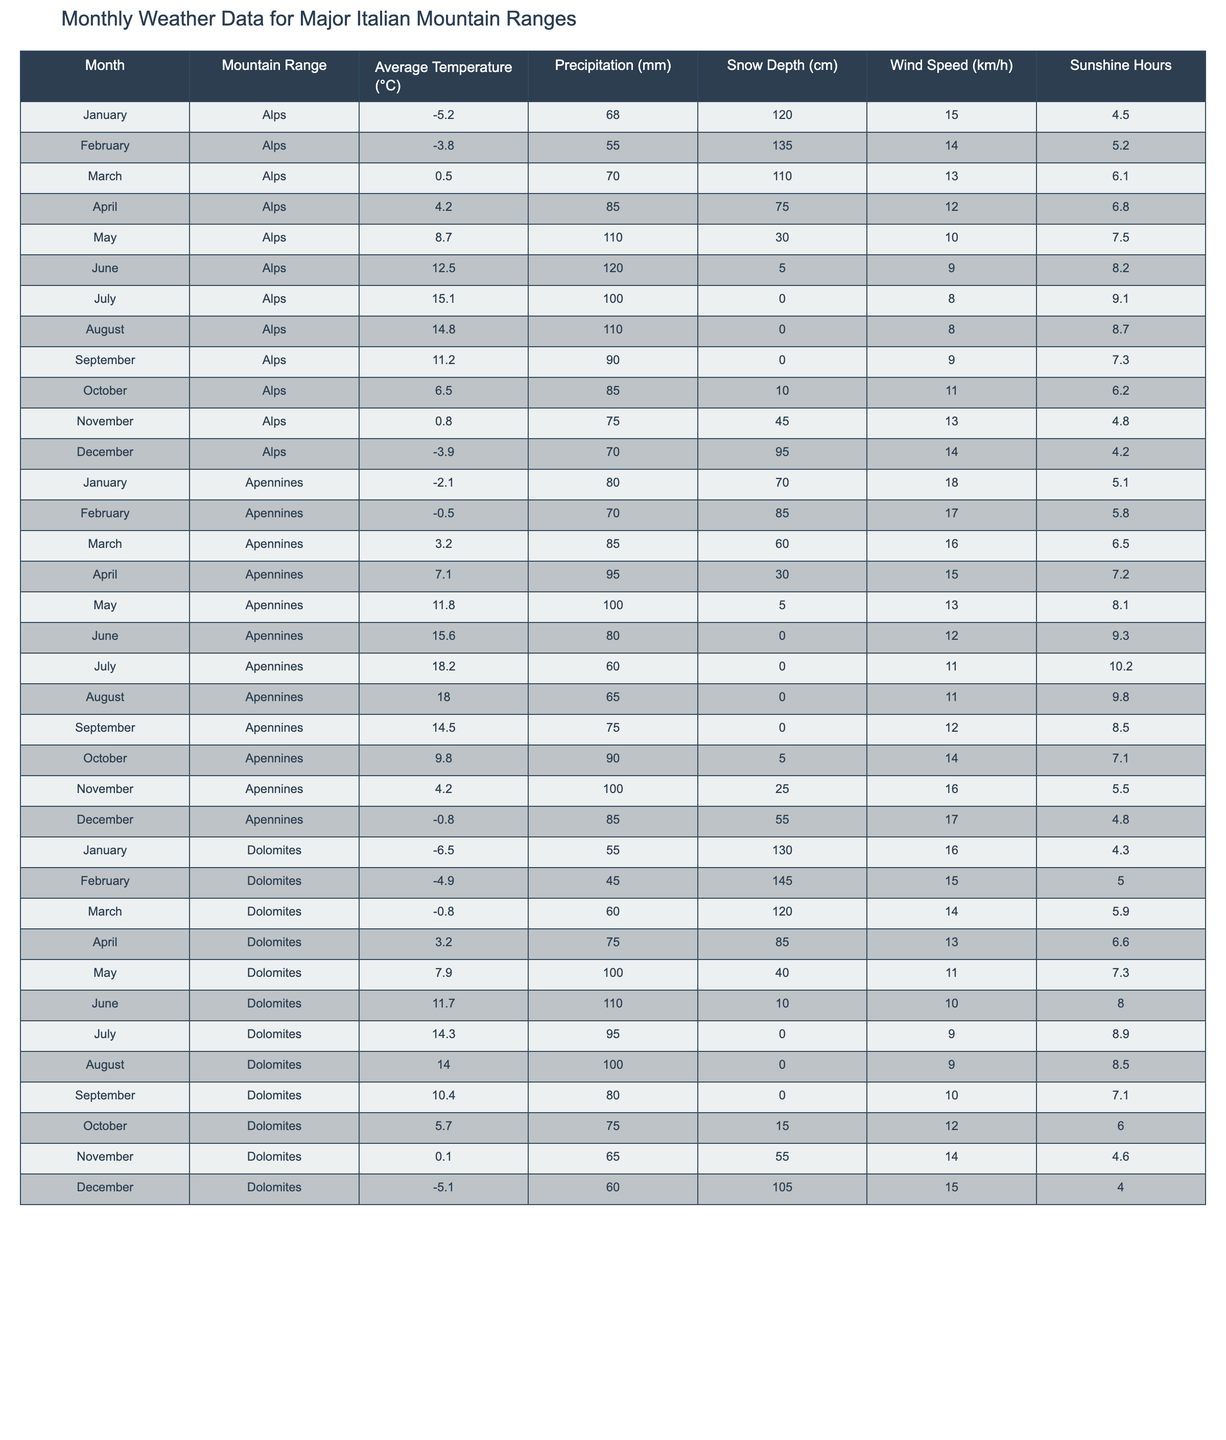What's the average temperature in July for the Alps? In July, the average temperature for the Alps is listed as 15.1°C, which we can directly retrieve from the table.
Answer: 15.1°C How much precipitation is recorded in September for the Apennines? The table shows that in September, the precipitation for the Apennines is 75 mm.
Answer: 75 mm What is the highest average temperature in the Dolomites, and in which month does it occur? The highest average temperature in the Dolomites is 14.3°C, which occurs in July. This information is found directly by comparing monthly temperature values in the table.
Answer: 14.3°C in July During which month does the Alps experience the most snow depth on average? The table indicates that January has the highest snow depth of 120 cm in the Alps, making it the month with the most snowfall.
Answer: January Is the average temperature in April for the Apennines higher than that for the Dolomites? The average temperature for the Apennines in April is 7.1°C, while for the Dolomites, it is 3.2°C, which confirms that the Apennines' temperature is higher.
Answer: Yes What is the difference in average temperature between the highest month of July for the Apennines and the lowest month of January for the Dolomites? The average temperature in July for the Apennines is 18.2°C and in January for the Dolomites, it is -6.5°C. The difference is 18.2 - (-6.5) = 24.7°C.
Answer: 24.7°C Which mountain range shows a consistent increase in average temperature from January to July? By checking the monthly averages in the table, we notice that the Apennines exhibit a consistent increase in temperature from -2.1°C in January to 18.2°C in July.
Answer: Apennines What is the average snow depth across all months for the Dolomites? To calculate the average snow depth for the Dolomites, we sum the snow depth values for all months (130 + 145 + 120 + 85 + 40 + 10 + 0 + 0 + 0 + 15 + 55 + 105 = 705) and divide by the 12 months, resulting in an average of 58.75 cm.
Answer: 58.75 cm Is the average wind speed in the months of July and August for the Alps less than 10 km/h? The wind speeds in July and August for the Alps are 8 km/h and 8 km/h, respectively. Since both wind speeds are less than 10 km/h, the statement is true.
Answer: Yes Which month in the Dolomites has the least amount of sunshine hours, and how many are there? In December, the Dolomites have the least sunshine hours, recorded as 4.0 hours. This is identified by comparing the sunshine hour values listed in the table for each month.
Answer: December, 4.0 hours 